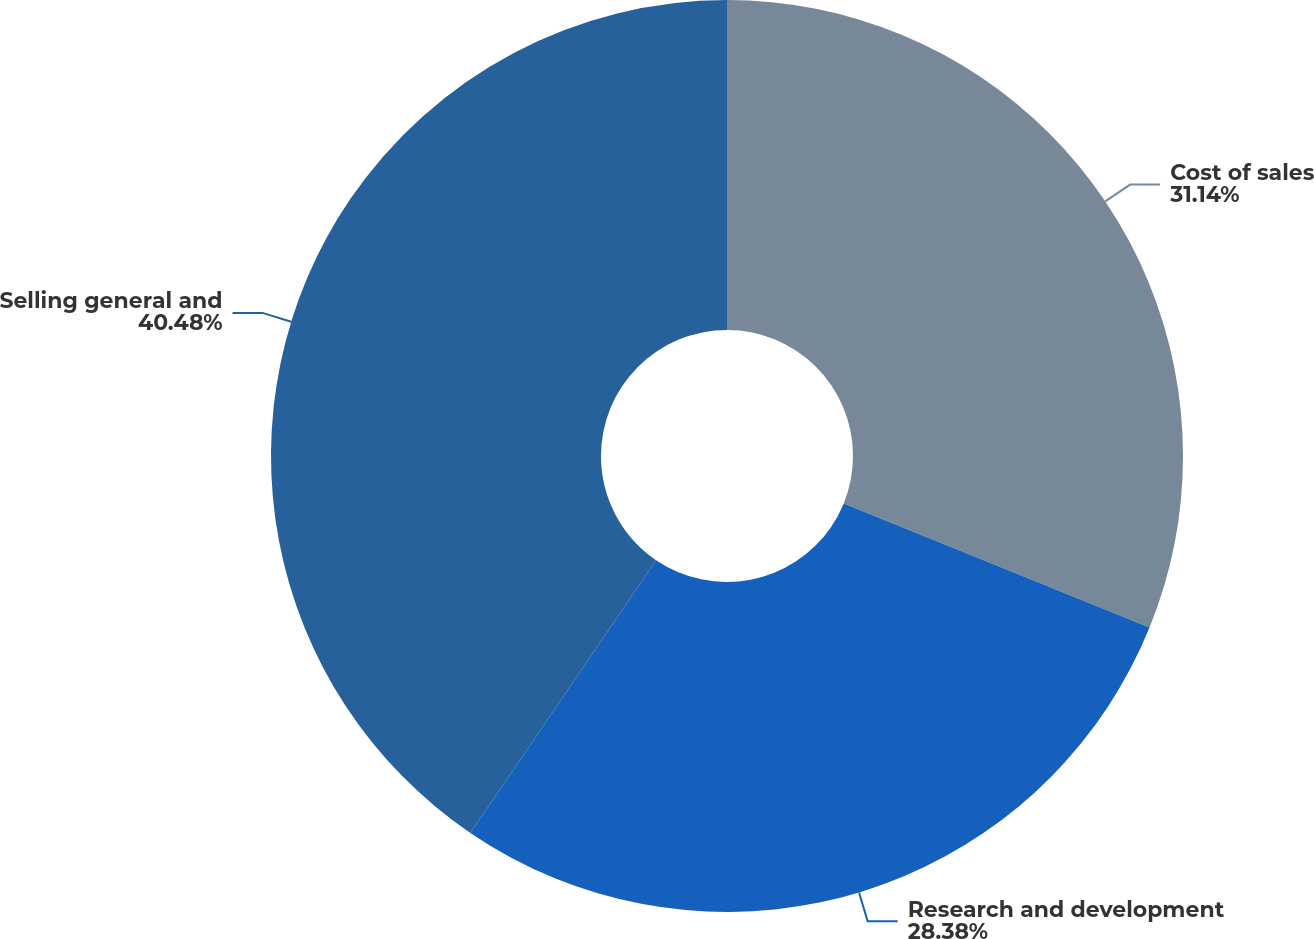<chart> <loc_0><loc_0><loc_500><loc_500><pie_chart><fcel>Cost of sales<fcel>Research and development<fcel>Selling general and<nl><fcel>31.14%<fcel>28.38%<fcel>40.49%<nl></chart> 